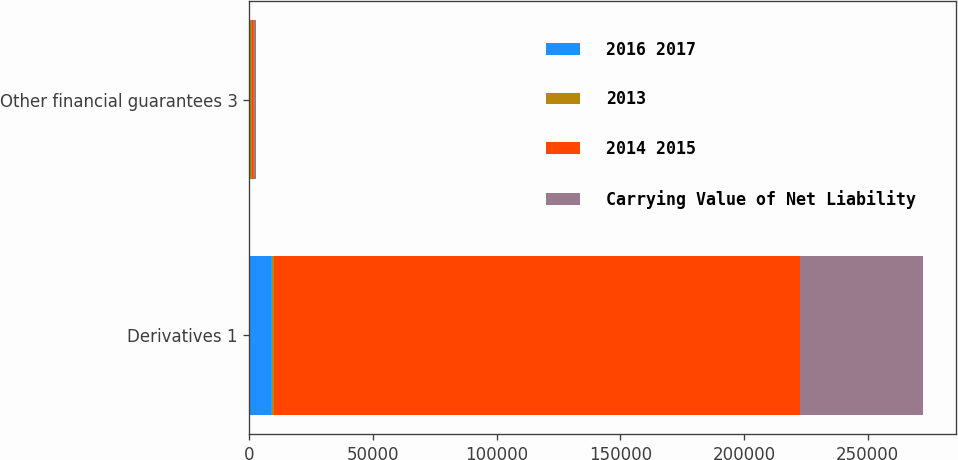<chart> <loc_0><loc_0><loc_500><loc_500><stacked_bar_chart><ecel><fcel>Derivatives 1<fcel>Other financial guarantees 3<nl><fcel>2016 2017<fcel>8581<fcel>152<nl><fcel>2013<fcel>1195<fcel>904<nl><fcel>2014 2015<fcel>213012<fcel>442<nl><fcel>Carrying Value of Net Liability<fcel>49413<fcel>1195<nl></chart> 